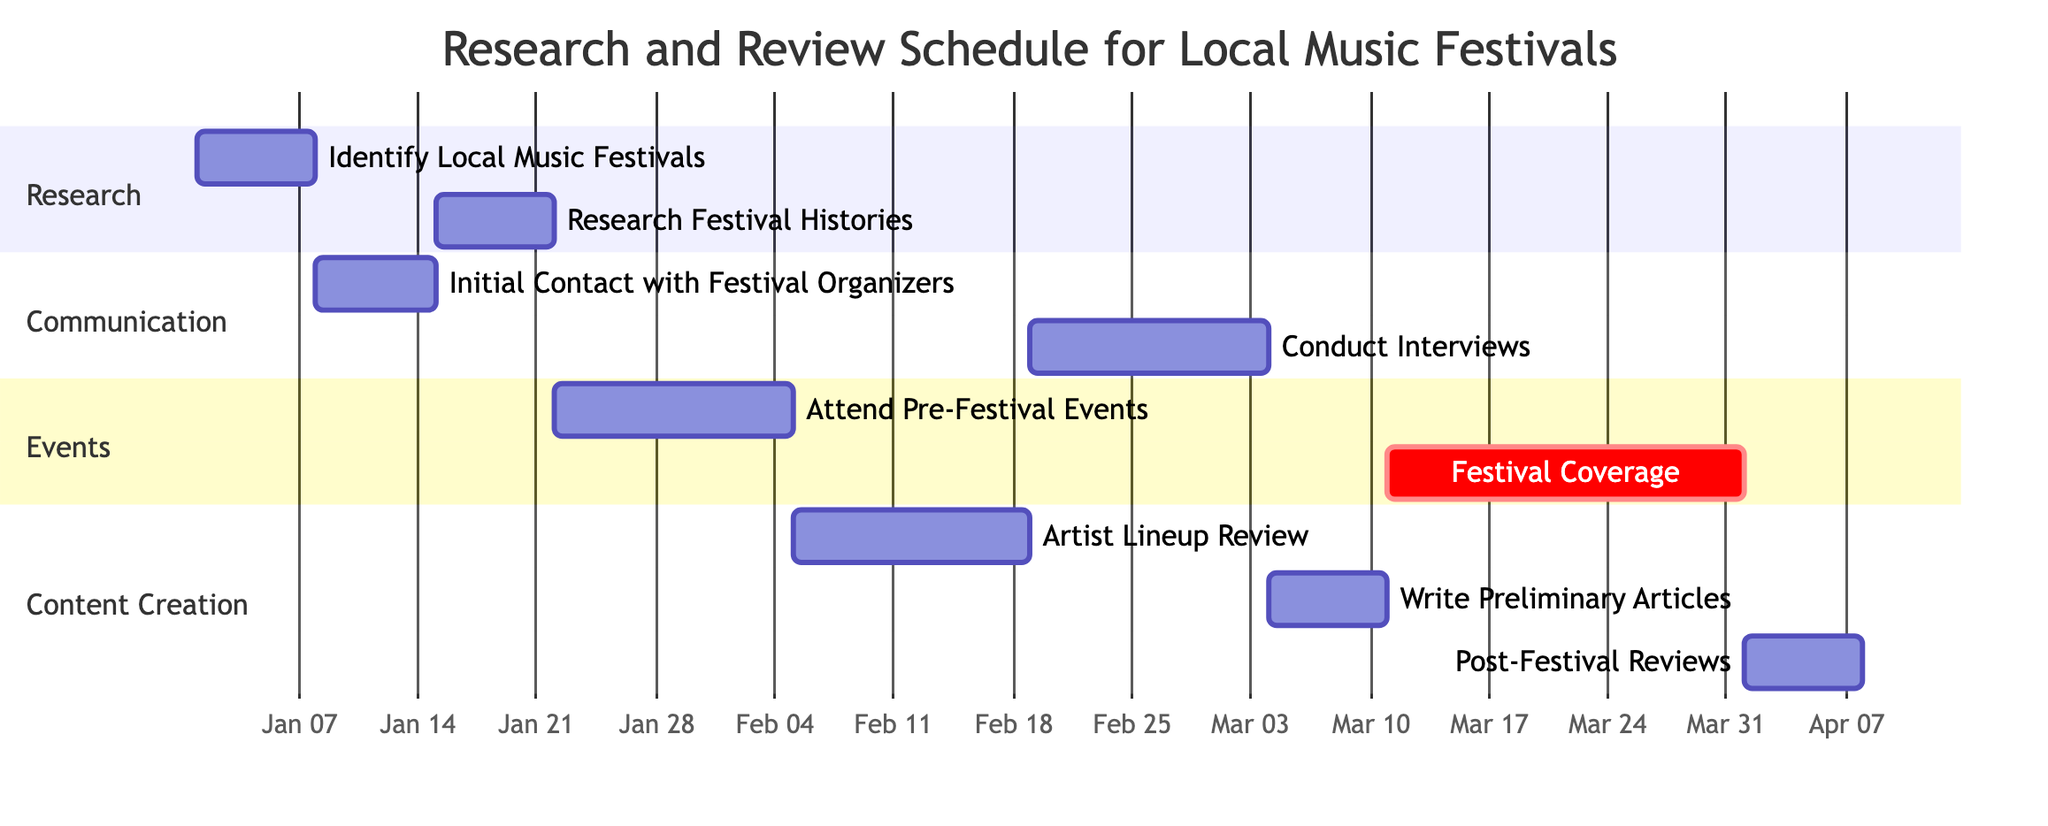What is the duration for the "Identify Local Music Festivals" task? The task starts on January 1, 2024, and ends on January 7, 2024, which gives it a duration of 7 days.
Answer: 7 days Which task starts immediately after the "Initial Contact with Festival Organizers"? The "Research Festival Histories" task starts on January 15, 2024, which is the day after the "Initial Contact with Festival Organizers" ends on January 14, 2024.
Answer: Research Festival Histories How many total tasks are there in the Gantt Chart? There are a total of 9 tasks listed in the data provided within the Gantt Chart.
Answer: 9 What is the description of the "Post-Festival Reviews" task? The description states that it involves writing and publishing reviews after attending the festivals, specifically from April 1, 2024, to April 7, 2024.
Answer: Write and publish reviews after attending the festivals Which section includes the "Festival Coverage" task? The "Festival Coverage" task is included in the "Events" section of the Gantt Chart, as indicated by how tasks are categorized.
Answer: Events What task is scheduled right before "Write Preliminary Articles"? The task "Artist Lineup Review" is scheduled right before "Write Preliminary Articles," running from February 5, 2024, to February 18, 2024.
Answer: Artist Lineup Review What is the relationship between "Conduct Interviews" and "Attend Pre-Festival Events"? "Attend Pre-Festival Events" occurs between January 22 and February 4, 2024, while "Conduct Interviews" starts later on February 19, 2024; they are sequential but not overlapping, indicating a clear order in the interviews happening post-pre-festival events.
Answer: Sequential relation When does the "Festival Coverage" period end? The "Festival Coverage" period that starts on March 11, 2024, ends on March 31, 2024, as per the given data in the diagram.
Answer: March 31, 2024 How long does the "Conduct Interviews" task last? This task starts on February 19, 2024, and ends on March 3, 2024, resulting in a total duration of 14 days.
Answer: 14 days 